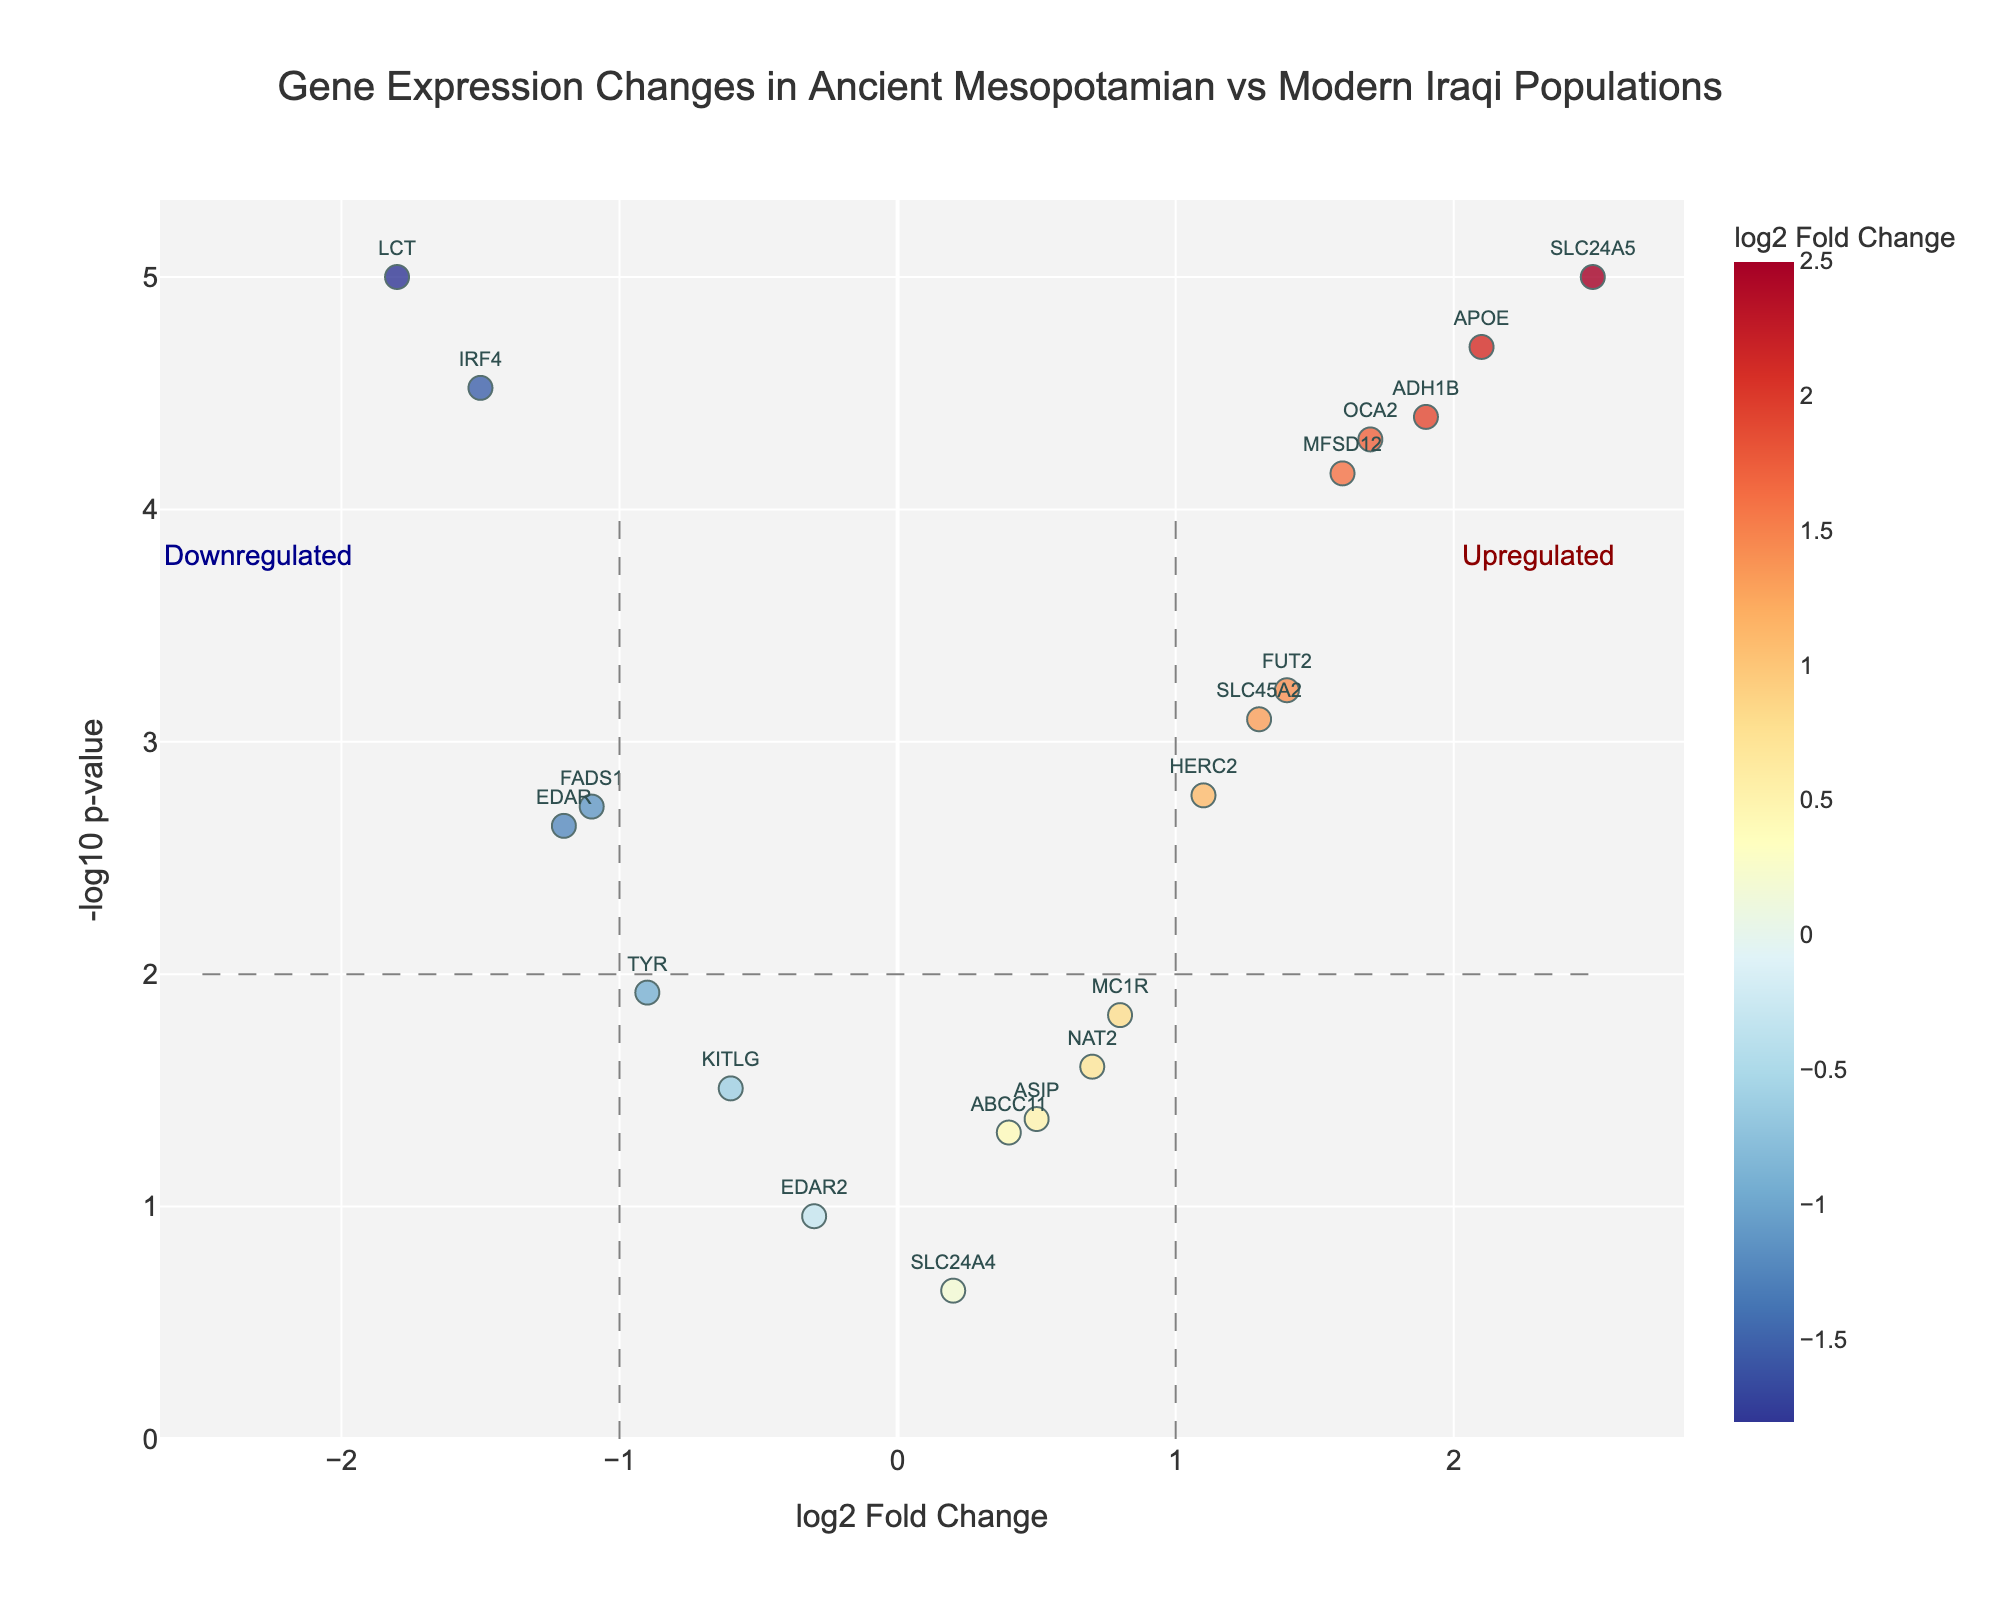What is the title of the figure? The title is displayed at the top of the figure. It reads: "Gene Expression Changes in Ancient Mesopotamian vs Modern Iraqi Populations".
Answer: Gene Expression Changes in Ancient Mesopotamian vs Modern Iraqi Populations What do the x and y-axis represent on the volcano plot? The x-axis represents the log2 Fold Change of gene expression, while the y-axis represents the -log10 p-value of the significance of the changes. These are typical axes for a volcano plot.
Answer: x-axis: log2 Fold Change, y-axis: -log10 p-value What color scale is used to represent the log2 Fold Change in the plot? The color of the points is determined by their log2 Fold Change values, using a scale from blue (downregulated) to red (upregulated), with intermediate values shown in shades of yellow. This can be inferred by looking at the continuous color scale on the plot.
Answer: Blue to Red (RdYlBu_r) Which gene has the highest log2 Fold Change and what is its value? By observing the x-axis and locating the gene with the highest positive log2 Fold Change value, SLC24A5 has the highest log2 Fold Change, which is 2.5.
Answer: SLC24A5, 2.5 How many genes are significantly upregulated (log2 Fold Change > 1 and -log10 p-value > 2)? First identify points to the right side of the vertical line at log2 Fold Change = 1. Then count the points above the horizontal line at -log10 p-value = 2. The upregulated genes satisfying both conditions are SLC24A5, APOE, ADH1B, FUT2, and MFSD12, totaling 5 genes.
Answer: 5 Which gene has the lowest p-value and how do you know? By identifying the highest point on the y-axis, which corresponds to the smallest p-value. The gene with the highest -log10 p-value is SLC24A5.
Answer: SLC24A5 Are there more downregulated or upregulated genes, and by how much? To determine this, count the genes with negative log2 Fold Change and compare with the count of genes with positive log2 Fold Change. There are 6 downregulated genes (EDAR, KITLG, TYR, LCT, IRF4, FADS1) and 12 upregulated genes (SLC24A5, MC1R, OCA2, SLC45A2, ASIP, HERC2, NAT2, ADH1B, FUT2, MFSD12, ABCC11, SLC24A4), so there are 6 more upregulated genes.
Answer: 6 more upregulated Which genes have a log2 Fold Change between -1 and 1 and a p-value less significant than 0.05? Look for genes within -1 and 1 log2 Fold Change and below the horizontal line at -log10 p-value = 1.3 (since 0.05 = -1.3 in -log10 scale). The genes meeting these criteria are ABCC11, EDAR2, SLC24A4.
Answer: ABCC11, EDAR2, SLC24A4 Among the genes with a log2 Fold Change less than -1, which one has the least significant p-value? First identify genes with log2 Fold Change less than -1. Then identify the one with the lowest point on the y-axis, which is EDAR.
Answer: EDAR 